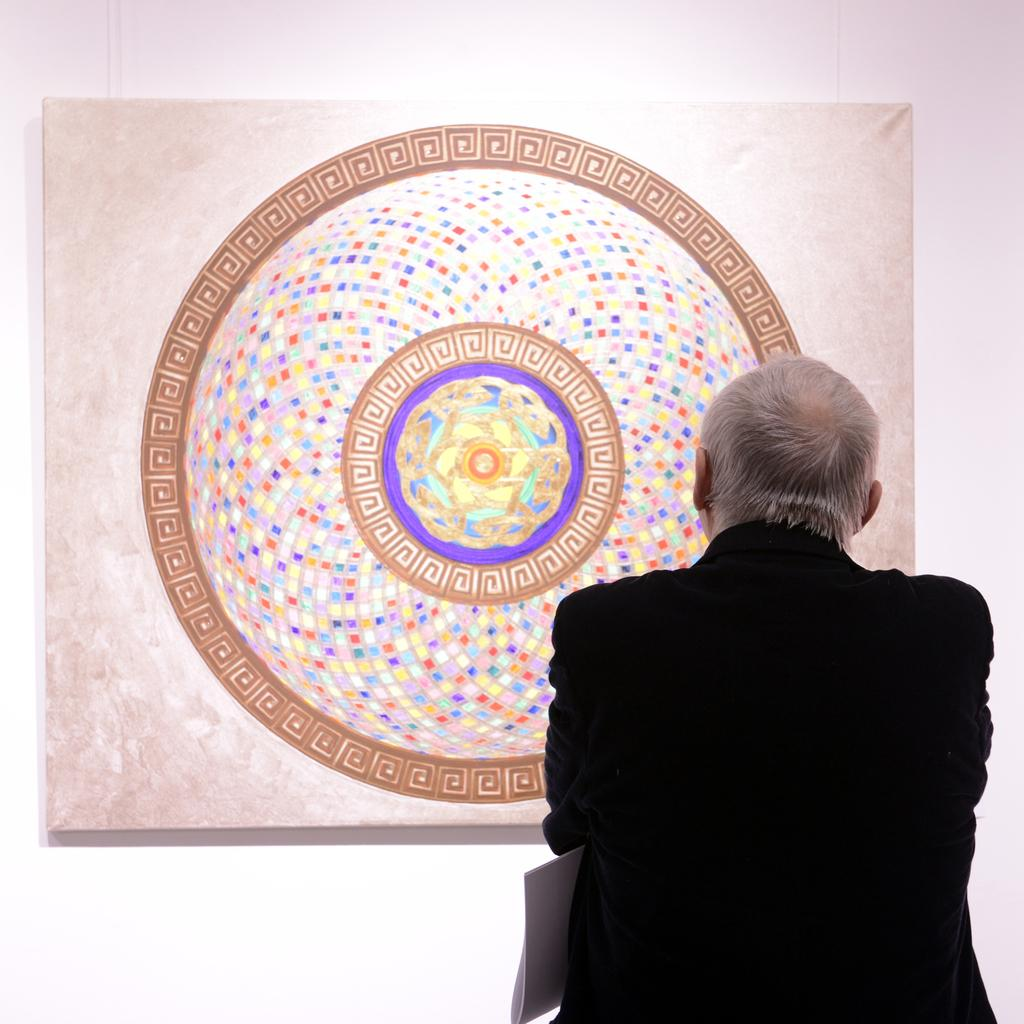What is present in the image? There is a person in the image. What can be seen attached to the wall in the image? There is a board attached to the wall in the image. What type of flame can be seen on the person's back in the image? There is no flame present in the image, nor is there any reference to a person's back. 